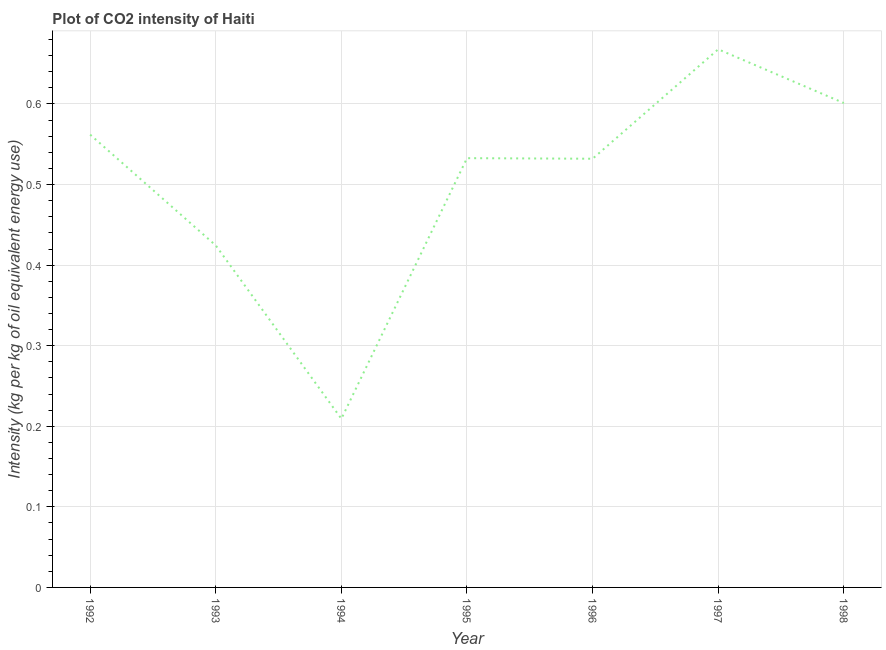What is the co2 intensity in 1998?
Make the answer very short. 0.6. Across all years, what is the maximum co2 intensity?
Keep it short and to the point. 0.67. Across all years, what is the minimum co2 intensity?
Make the answer very short. 0.21. In which year was the co2 intensity minimum?
Your response must be concise. 1994. What is the sum of the co2 intensity?
Give a very brief answer. 3.53. What is the difference between the co2 intensity in 1992 and 1993?
Your answer should be very brief. 0.14. What is the average co2 intensity per year?
Your response must be concise. 0.5. What is the median co2 intensity?
Ensure brevity in your answer.  0.53. In how many years, is the co2 intensity greater than 0.36000000000000004 kg?
Your response must be concise. 6. What is the ratio of the co2 intensity in 1993 to that in 1996?
Your answer should be very brief. 0.8. What is the difference between the highest and the second highest co2 intensity?
Give a very brief answer. 0.07. Is the sum of the co2 intensity in 1997 and 1998 greater than the maximum co2 intensity across all years?
Make the answer very short. Yes. What is the difference between the highest and the lowest co2 intensity?
Provide a succinct answer. 0.46. Does the co2 intensity monotonically increase over the years?
Give a very brief answer. No. What is the difference between two consecutive major ticks on the Y-axis?
Give a very brief answer. 0.1. Are the values on the major ticks of Y-axis written in scientific E-notation?
Give a very brief answer. No. Does the graph contain any zero values?
Offer a terse response. No. Does the graph contain grids?
Offer a terse response. Yes. What is the title of the graph?
Ensure brevity in your answer.  Plot of CO2 intensity of Haiti. What is the label or title of the X-axis?
Offer a very short reply. Year. What is the label or title of the Y-axis?
Keep it short and to the point. Intensity (kg per kg of oil equivalent energy use). What is the Intensity (kg per kg of oil equivalent energy use) in 1992?
Your answer should be compact. 0.56. What is the Intensity (kg per kg of oil equivalent energy use) of 1993?
Your response must be concise. 0.42. What is the Intensity (kg per kg of oil equivalent energy use) of 1994?
Your answer should be compact. 0.21. What is the Intensity (kg per kg of oil equivalent energy use) of 1995?
Provide a succinct answer. 0.53. What is the Intensity (kg per kg of oil equivalent energy use) of 1996?
Offer a very short reply. 0.53. What is the Intensity (kg per kg of oil equivalent energy use) of 1997?
Your response must be concise. 0.67. What is the Intensity (kg per kg of oil equivalent energy use) of 1998?
Offer a very short reply. 0.6. What is the difference between the Intensity (kg per kg of oil equivalent energy use) in 1992 and 1993?
Provide a succinct answer. 0.14. What is the difference between the Intensity (kg per kg of oil equivalent energy use) in 1992 and 1994?
Keep it short and to the point. 0.35. What is the difference between the Intensity (kg per kg of oil equivalent energy use) in 1992 and 1995?
Ensure brevity in your answer.  0.03. What is the difference between the Intensity (kg per kg of oil equivalent energy use) in 1992 and 1996?
Your answer should be compact. 0.03. What is the difference between the Intensity (kg per kg of oil equivalent energy use) in 1992 and 1997?
Make the answer very short. -0.11. What is the difference between the Intensity (kg per kg of oil equivalent energy use) in 1992 and 1998?
Offer a very short reply. -0.04. What is the difference between the Intensity (kg per kg of oil equivalent energy use) in 1993 and 1994?
Provide a short and direct response. 0.22. What is the difference between the Intensity (kg per kg of oil equivalent energy use) in 1993 and 1995?
Your response must be concise. -0.11. What is the difference between the Intensity (kg per kg of oil equivalent energy use) in 1993 and 1996?
Give a very brief answer. -0.11. What is the difference between the Intensity (kg per kg of oil equivalent energy use) in 1993 and 1997?
Make the answer very short. -0.24. What is the difference between the Intensity (kg per kg of oil equivalent energy use) in 1993 and 1998?
Provide a short and direct response. -0.18. What is the difference between the Intensity (kg per kg of oil equivalent energy use) in 1994 and 1995?
Offer a very short reply. -0.32. What is the difference between the Intensity (kg per kg of oil equivalent energy use) in 1994 and 1996?
Ensure brevity in your answer.  -0.32. What is the difference between the Intensity (kg per kg of oil equivalent energy use) in 1994 and 1997?
Provide a succinct answer. -0.46. What is the difference between the Intensity (kg per kg of oil equivalent energy use) in 1994 and 1998?
Ensure brevity in your answer.  -0.39. What is the difference between the Intensity (kg per kg of oil equivalent energy use) in 1995 and 1996?
Keep it short and to the point. 0. What is the difference between the Intensity (kg per kg of oil equivalent energy use) in 1995 and 1997?
Provide a short and direct response. -0.14. What is the difference between the Intensity (kg per kg of oil equivalent energy use) in 1995 and 1998?
Keep it short and to the point. -0.07. What is the difference between the Intensity (kg per kg of oil equivalent energy use) in 1996 and 1997?
Give a very brief answer. -0.14. What is the difference between the Intensity (kg per kg of oil equivalent energy use) in 1996 and 1998?
Provide a succinct answer. -0.07. What is the difference between the Intensity (kg per kg of oil equivalent energy use) in 1997 and 1998?
Provide a succinct answer. 0.07. What is the ratio of the Intensity (kg per kg of oil equivalent energy use) in 1992 to that in 1993?
Make the answer very short. 1.32. What is the ratio of the Intensity (kg per kg of oil equivalent energy use) in 1992 to that in 1994?
Ensure brevity in your answer.  2.69. What is the ratio of the Intensity (kg per kg of oil equivalent energy use) in 1992 to that in 1995?
Ensure brevity in your answer.  1.05. What is the ratio of the Intensity (kg per kg of oil equivalent energy use) in 1992 to that in 1996?
Provide a succinct answer. 1.06. What is the ratio of the Intensity (kg per kg of oil equivalent energy use) in 1992 to that in 1997?
Your answer should be compact. 0.84. What is the ratio of the Intensity (kg per kg of oil equivalent energy use) in 1992 to that in 1998?
Offer a terse response. 0.94. What is the ratio of the Intensity (kg per kg of oil equivalent energy use) in 1993 to that in 1994?
Provide a succinct answer. 2.03. What is the ratio of the Intensity (kg per kg of oil equivalent energy use) in 1993 to that in 1995?
Keep it short and to the point. 0.8. What is the ratio of the Intensity (kg per kg of oil equivalent energy use) in 1993 to that in 1996?
Give a very brief answer. 0.8. What is the ratio of the Intensity (kg per kg of oil equivalent energy use) in 1993 to that in 1997?
Offer a very short reply. 0.64. What is the ratio of the Intensity (kg per kg of oil equivalent energy use) in 1993 to that in 1998?
Ensure brevity in your answer.  0.71. What is the ratio of the Intensity (kg per kg of oil equivalent energy use) in 1994 to that in 1995?
Your answer should be compact. 0.39. What is the ratio of the Intensity (kg per kg of oil equivalent energy use) in 1994 to that in 1996?
Give a very brief answer. 0.39. What is the ratio of the Intensity (kg per kg of oil equivalent energy use) in 1994 to that in 1997?
Keep it short and to the point. 0.31. What is the ratio of the Intensity (kg per kg of oil equivalent energy use) in 1994 to that in 1998?
Give a very brief answer. 0.35. What is the ratio of the Intensity (kg per kg of oil equivalent energy use) in 1995 to that in 1996?
Your response must be concise. 1. What is the ratio of the Intensity (kg per kg of oil equivalent energy use) in 1995 to that in 1997?
Offer a terse response. 0.8. What is the ratio of the Intensity (kg per kg of oil equivalent energy use) in 1995 to that in 1998?
Your answer should be very brief. 0.89. What is the ratio of the Intensity (kg per kg of oil equivalent energy use) in 1996 to that in 1997?
Your answer should be very brief. 0.8. What is the ratio of the Intensity (kg per kg of oil equivalent energy use) in 1996 to that in 1998?
Your answer should be very brief. 0.89. What is the ratio of the Intensity (kg per kg of oil equivalent energy use) in 1997 to that in 1998?
Your response must be concise. 1.11. 